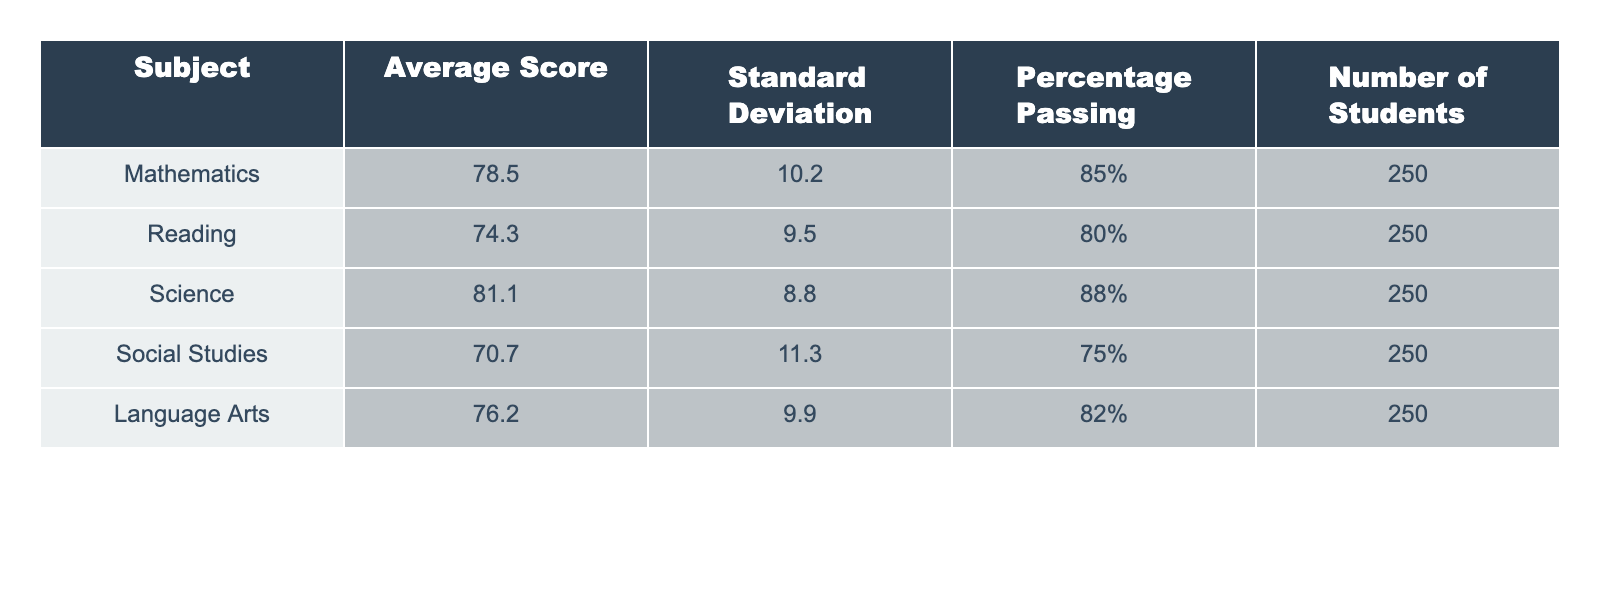What is the average score for Mathematics? The table shows that the average score for Mathematics is listed directly under the "Average Score" column for that subject, which is 78.5.
Answer: 78.5 What percentage of students passed the Science subject? Looking at the table, the "Percentage Passing" for Science is noted as 88%.
Answer: 88% Which subject has the highest average score? By comparing the average scores listed for each subject, Science has the highest average score at 81.1.
Answer: Science Is the average score for Reading greater than the average score for Social Studies? The average score for Reading is 74.3 and for Social Studies it is 70.7. Since 74.3 is greater than 70.7, the statement is true.
Answer: Yes What is the difference in average scores between Mathematics and Language Arts? The average score for Mathematics is 78.5 and for Language Arts it is 76.2. The difference is calculated as 78.5 - 76.2 = 2.3.
Answer: 2.3 How many students passed in Mathematics? To find the number of students who passed in Mathematics, we can multiply the total number of students (250) by the percentage passing (85%). 0.85 x 250 = 212.5, rounded down gives 212 students passing.
Answer: 212 What is the average of average scores for all subjects? The average score is calculated by adding all the average scores (78.5 + 74.3 + 81.1 + 70.7 + 76.2 = 380.8) and dividing by the number of subjects (5). So, 380.8 / 5 = 76.16.
Answer: 76.16 Which subject has the lowest percentage passing? The lowest percentage passing can be determined from the table, where Social Studies has a passing percentage of 75%, which is lower than the others.
Answer: Social Studies If 40 students failed in Reading, how many passed? If 40 students failed, then out of 250 students, the number who passed is 250 - 40 = 210.
Answer: 210 What is the standard deviation for Language Arts scores? The standard deviation value for Language Arts is directly given in the table as 9.9.
Answer: 9.9 